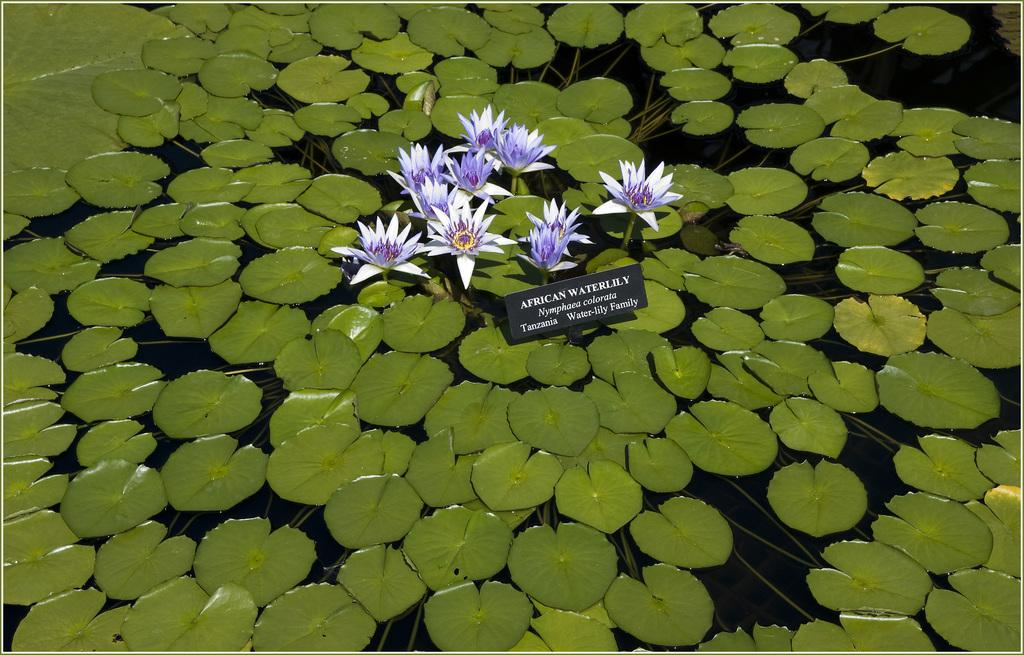What colors are the flowers in the image? The flowers in the image are in white and purple colors. What is the color of the board in the image? The board in the image is in black color. What color are the leaves in the image? The leaves in the image are in green color. Where are the leaves located in the image? The leaves are on the water. What type of cherry is floating on the table in the image? There is no cherry present in the image; the leaves are on the water. What is the border made of in the image? There is no border mentioned in the provided facts, so it cannot be determined from the image. 